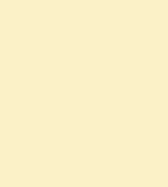Convert code to text. <code><loc_0><loc_0><loc_500><loc_500><_C_>
</code> 